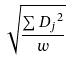<formula> <loc_0><loc_0><loc_500><loc_500>\sqrt { \frac { \sum { D _ { j } } ^ { 2 } } { w } }</formula> 